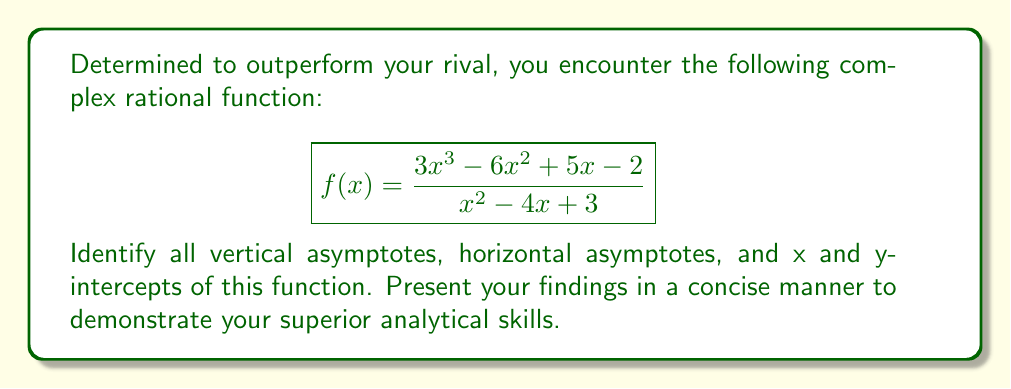Show me your answer to this math problem. Let's approach this step-by-step:

1. Vertical Asymptotes:
   Find the roots of the denominator:
   $$x^2 - 4x + 3 = (x - 1)(x - 3)$$
   Vertical asymptotes occur at $x = 1$ and $x = 3$

2. Horizontal Asymptote:
   Compare the degrees of numerator (3) and denominator (2):
   $$\lim_{x \to \infty} \frac{3x^3 - 6x^2 + 5x - 2}{x^2 - 4x + 3} = \lim_{x \to \infty} \frac{3x^3}{x^2} = \lim_{x \to \infty} 3x = \infty$$
   There is no horizontal asymptote; instead, there's a slant asymptote.

3. Slant Asymptote:
   Divide the numerator by the denominator:
   $$\frac{3x^3 - 6x^2 + 5x - 2}{x^2 - 4x + 3} = 3x + 6 + \frac{17x - 20}{x^2 - 4x + 3}$$
   The slant asymptote is $y = 3x + 6$

4. X-intercepts:
   Set the numerator to zero:
   $$3x^3 - 6x^2 + 5x - 2 = 0$$
   This cubic equation has one real root at $x = \frac{2}{3}$

5. Y-intercept:
   Set $x = 0$ in the original function:
   $$f(0) = \frac{-2}{3} = -\frac{2}{3}$$
Answer: Vertical asymptotes: $x = 1$, $x = 3$
Slant asymptote: $y = 3x + 6$
X-intercept: $(\frac{2}{3}, 0)$
Y-intercept: $(0, -\frac{2}{3})$ 